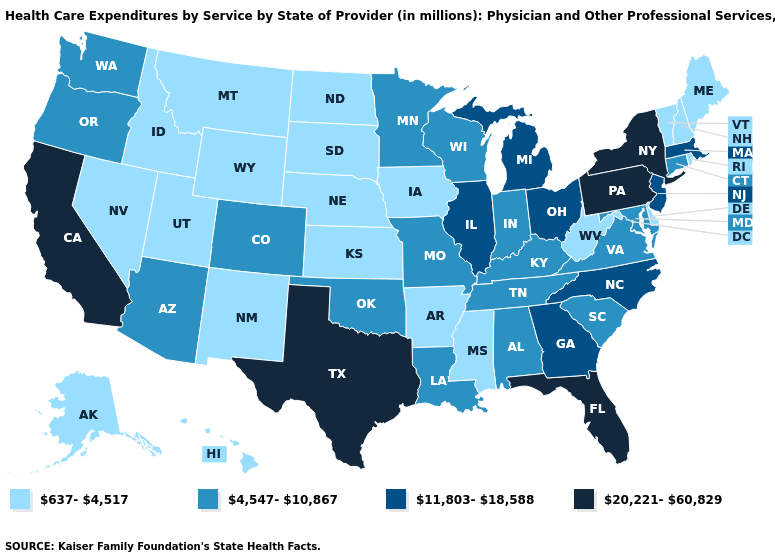Does South Carolina have the lowest value in the USA?
Give a very brief answer. No. What is the value of New Mexico?
Be succinct. 637-4,517. Does Idaho have the lowest value in the West?
Be succinct. Yes. What is the value of Massachusetts?
Write a very short answer. 11,803-18,588. Which states have the lowest value in the USA?
Keep it brief. Alaska, Arkansas, Delaware, Hawaii, Idaho, Iowa, Kansas, Maine, Mississippi, Montana, Nebraska, Nevada, New Hampshire, New Mexico, North Dakota, Rhode Island, South Dakota, Utah, Vermont, West Virginia, Wyoming. What is the lowest value in states that border New Mexico?
Quick response, please. 637-4,517. Name the states that have a value in the range 20,221-60,829?
Short answer required. California, Florida, New York, Pennsylvania, Texas. Among the states that border Delaware , does Pennsylvania have the lowest value?
Answer briefly. No. What is the value of Rhode Island?
Be succinct. 637-4,517. Does New Jersey have a higher value than Ohio?
Write a very short answer. No. Does Massachusetts have the lowest value in the Northeast?
Quick response, please. No. What is the value of South Carolina?
Answer briefly. 4,547-10,867. Name the states that have a value in the range 4,547-10,867?
Quick response, please. Alabama, Arizona, Colorado, Connecticut, Indiana, Kentucky, Louisiana, Maryland, Minnesota, Missouri, Oklahoma, Oregon, South Carolina, Tennessee, Virginia, Washington, Wisconsin. Name the states that have a value in the range 20,221-60,829?
Give a very brief answer. California, Florida, New York, Pennsylvania, Texas. Does Texas have the lowest value in the USA?
Write a very short answer. No. 